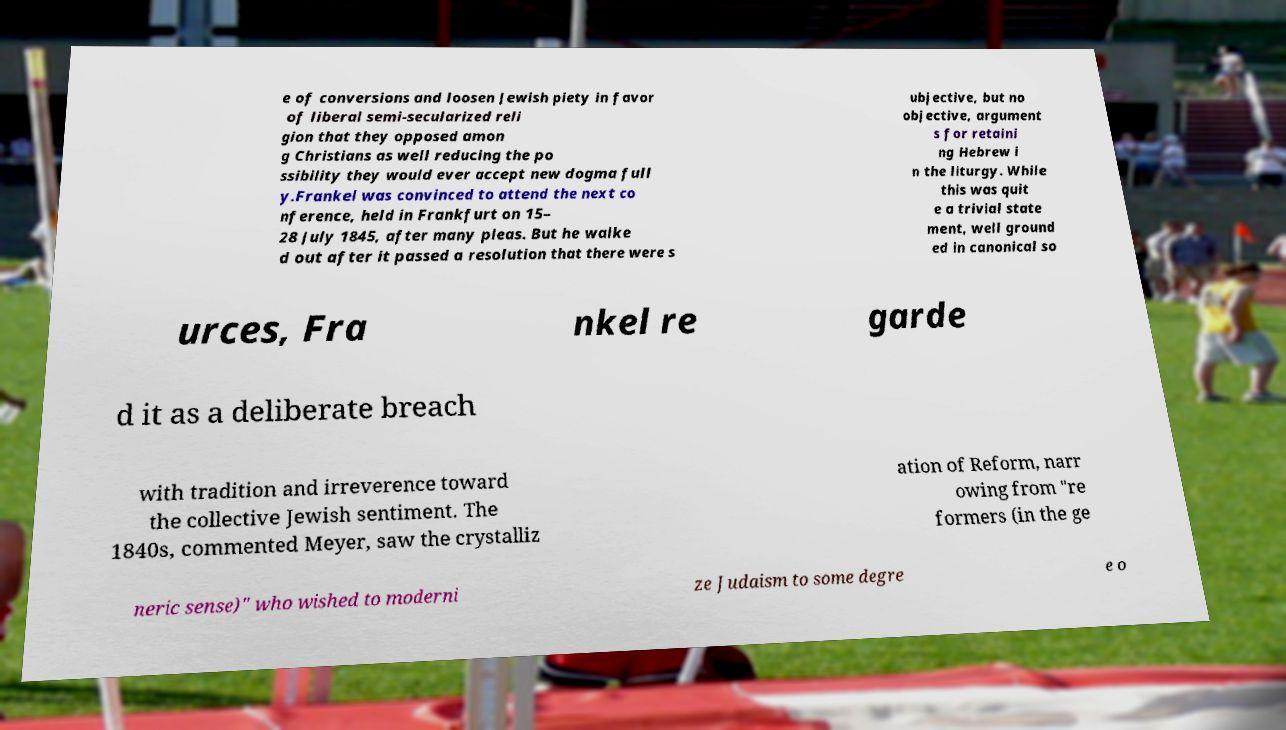I need the written content from this picture converted into text. Can you do that? e of conversions and loosen Jewish piety in favor of liberal semi-secularized reli gion that they opposed amon g Christians as well reducing the po ssibility they would ever accept new dogma full y.Frankel was convinced to attend the next co nference, held in Frankfurt on 15– 28 July 1845, after many pleas. But he walke d out after it passed a resolution that there were s ubjective, but no objective, argument s for retaini ng Hebrew i n the liturgy. While this was quit e a trivial state ment, well ground ed in canonical so urces, Fra nkel re garde d it as a deliberate breach with tradition and irreverence toward the collective Jewish sentiment. The 1840s, commented Meyer, saw the crystalliz ation of Reform, narr owing from "re formers (in the ge neric sense)" who wished to moderni ze Judaism to some degre e o 